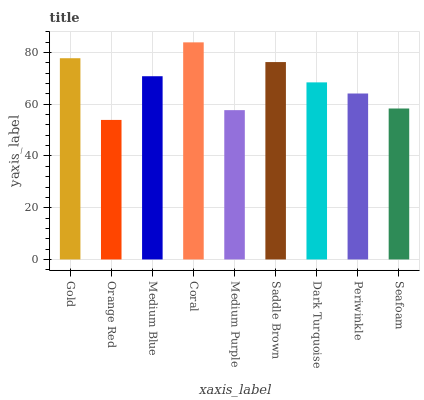Is Medium Blue the minimum?
Answer yes or no. No. Is Medium Blue the maximum?
Answer yes or no. No. Is Medium Blue greater than Orange Red?
Answer yes or no. Yes. Is Orange Red less than Medium Blue?
Answer yes or no. Yes. Is Orange Red greater than Medium Blue?
Answer yes or no. No. Is Medium Blue less than Orange Red?
Answer yes or no. No. Is Dark Turquoise the high median?
Answer yes or no. Yes. Is Dark Turquoise the low median?
Answer yes or no. Yes. Is Gold the high median?
Answer yes or no. No. Is Medium Purple the low median?
Answer yes or no. No. 